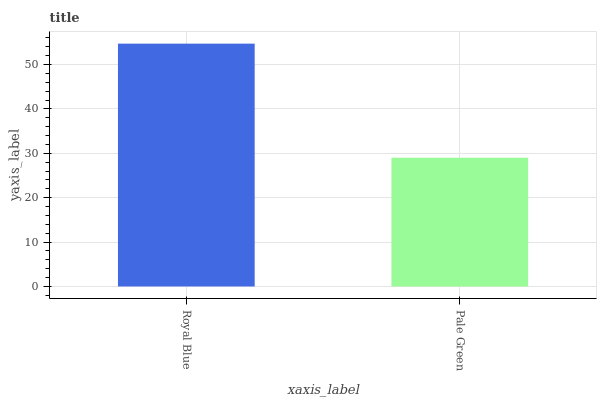Is Pale Green the minimum?
Answer yes or no. Yes. Is Royal Blue the maximum?
Answer yes or no. Yes. Is Pale Green the maximum?
Answer yes or no. No. Is Royal Blue greater than Pale Green?
Answer yes or no. Yes. Is Pale Green less than Royal Blue?
Answer yes or no. Yes. Is Pale Green greater than Royal Blue?
Answer yes or no. No. Is Royal Blue less than Pale Green?
Answer yes or no. No. Is Royal Blue the high median?
Answer yes or no. Yes. Is Pale Green the low median?
Answer yes or no. Yes. Is Pale Green the high median?
Answer yes or no. No. Is Royal Blue the low median?
Answer yes or no. No. 